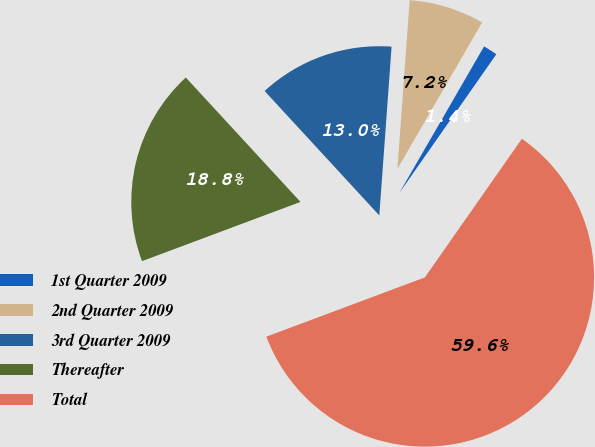<chart> <loc_0><loc_0><loc_500><loc_500><pie_chart><fcel>1st Quarter 2009<fcel>2nd Quarter 2009<fcel>3rd Quarter 2009<fcel>Thereafter<fcel>Total<nl><fcel>1.37%<fcel>7.19%<fcel>13.01%<fcel>18.84%<fcel>59.59%<nl></chart> 